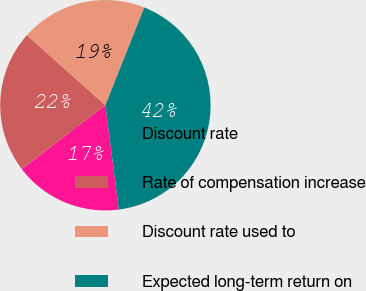Convert chart. <chart><loc_0><loc_0><loc_500><loc_500><pie_chart><fcel>Discount rate<fcel>Rate of compensation increase<fcel>Discount rate used to<fcel>Expected long-term return on<nl><fcel>16.66%<fcel>21.98%<fcel>19.44%<fcel>41.93%<nl></chart> 